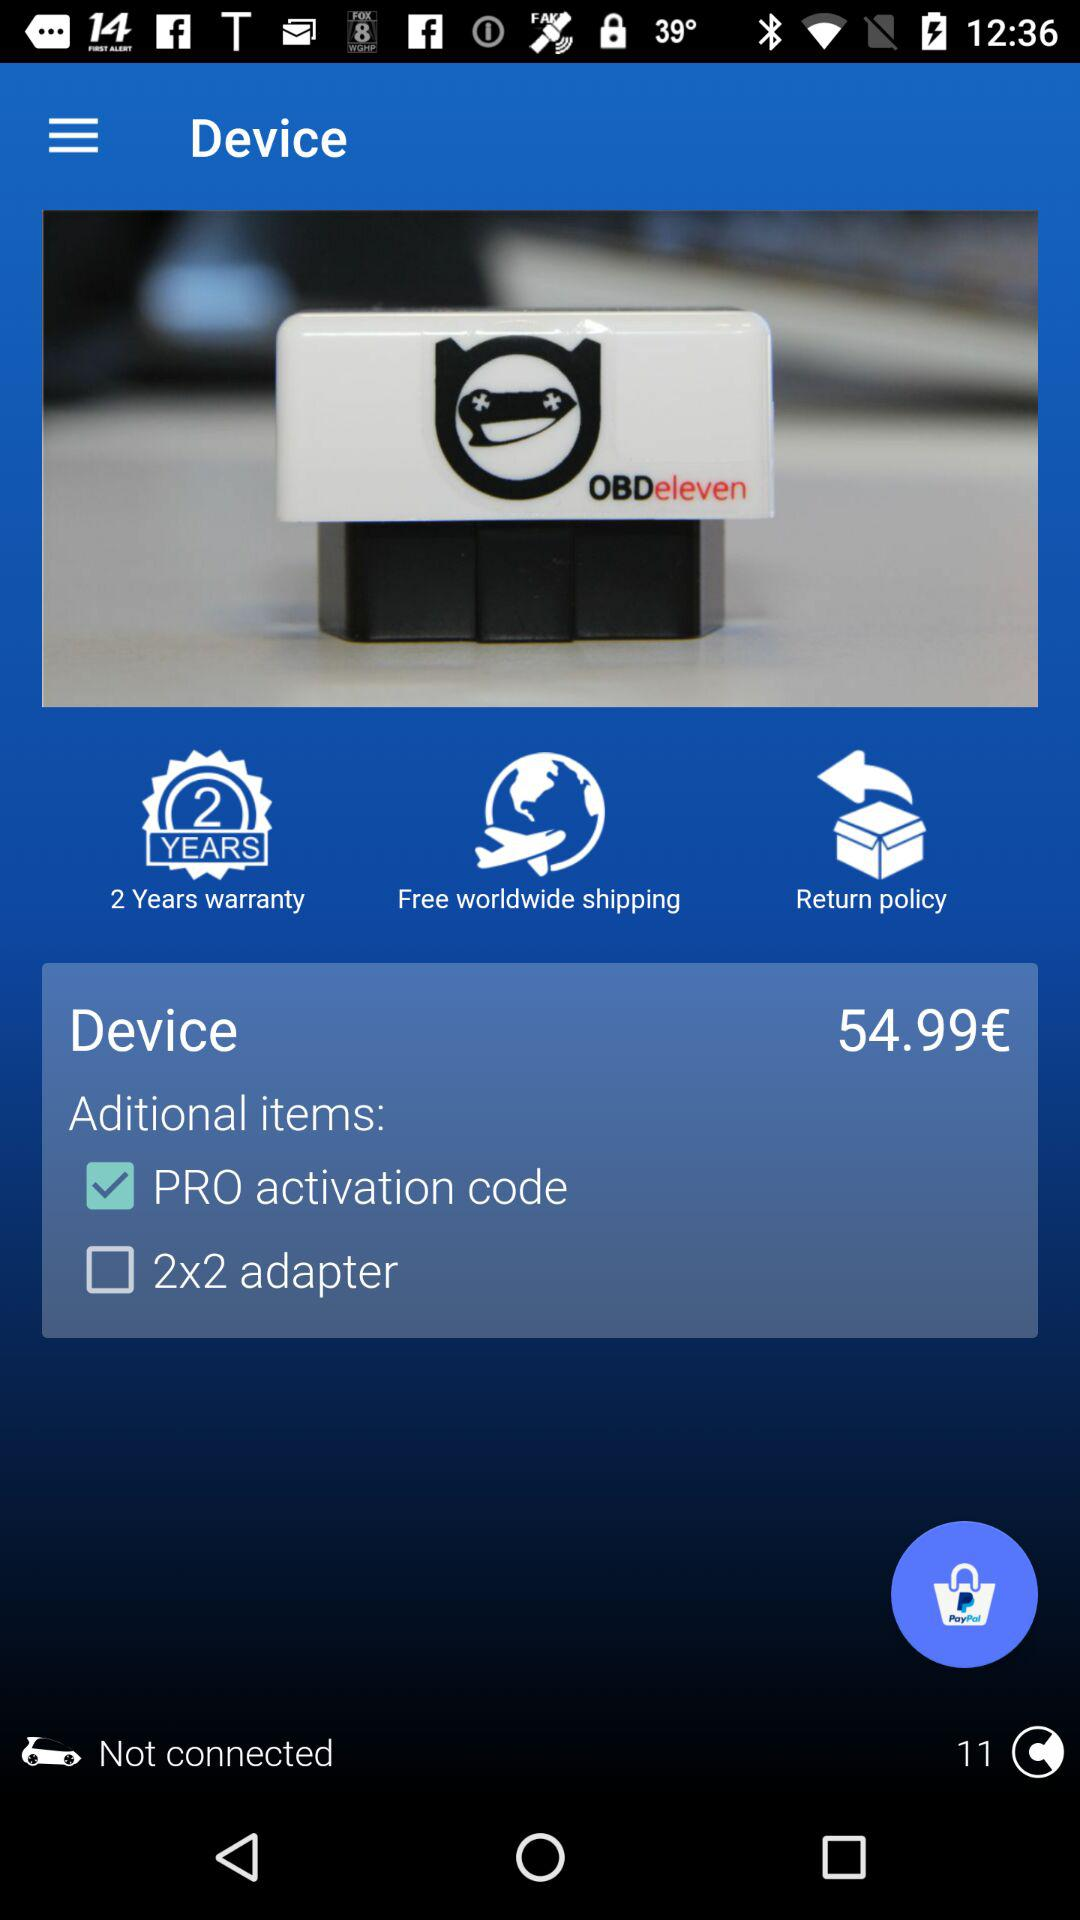How many items are in the cart?
Answer the question using a single word or phrase. 2 